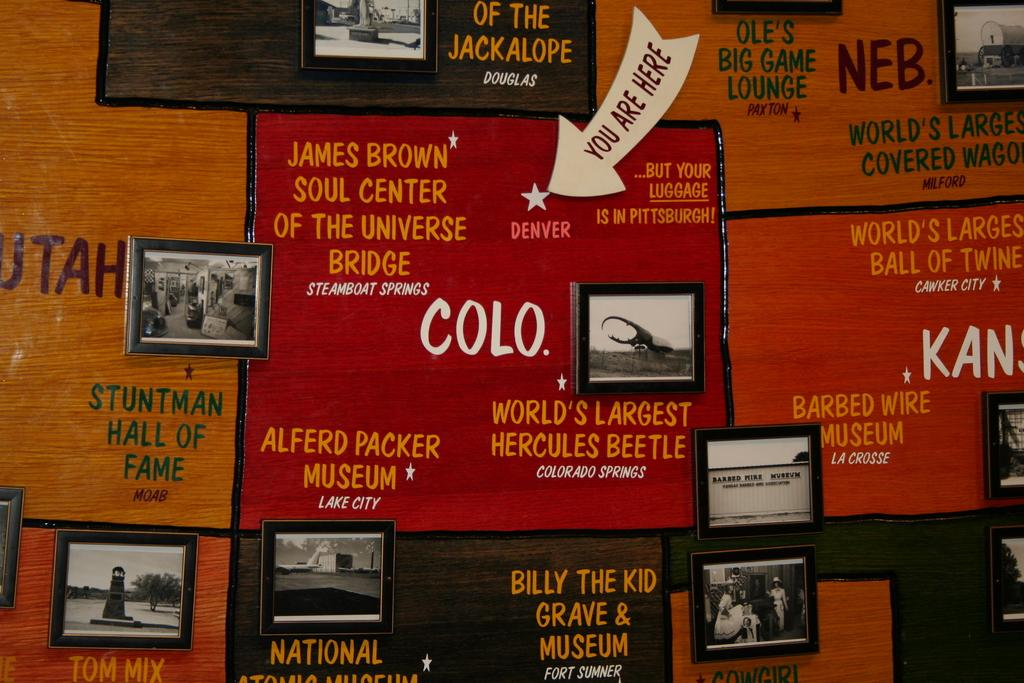<image>
Render a clear and concise summary of the photo. A wall of ads for museums and halls of fame. 